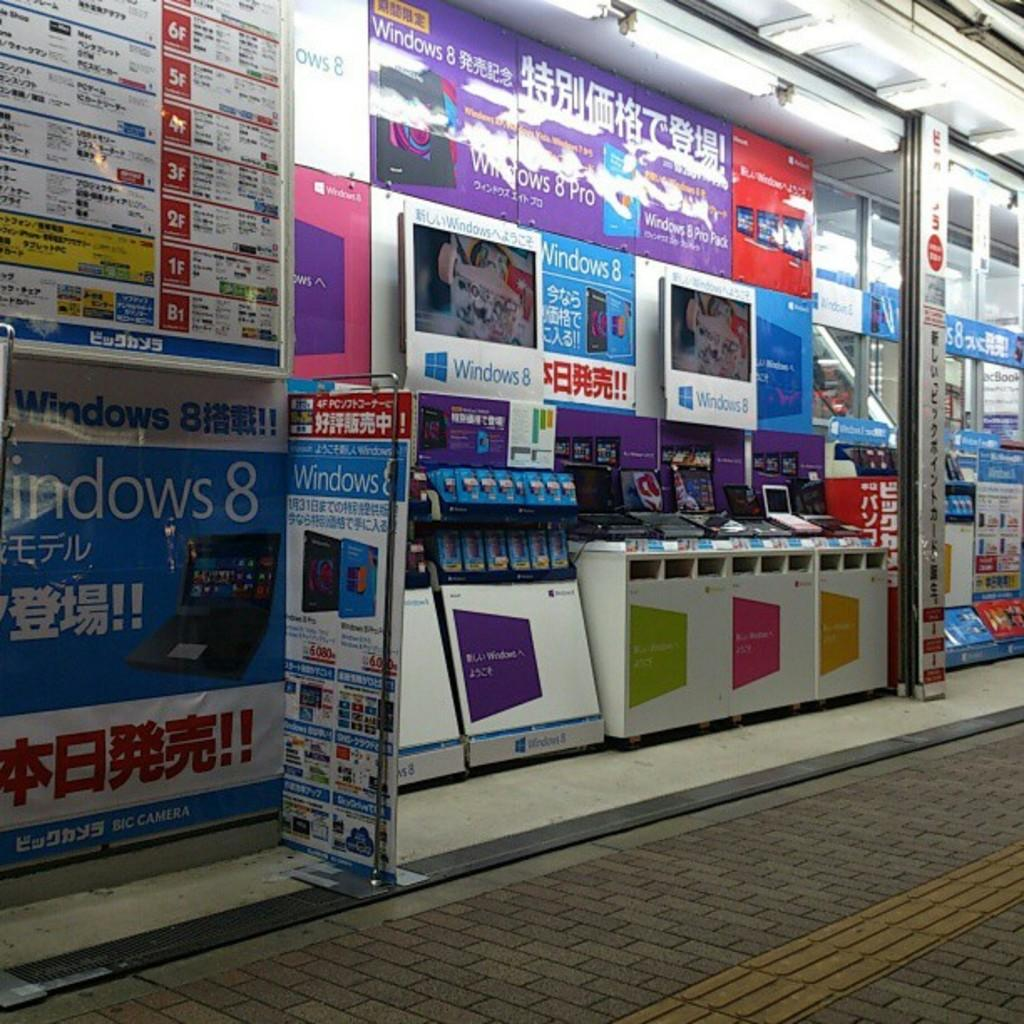<image>
Give a short and clear explanation of the subsequent image. A colorful wall includes ads for Windows 8 that are blue. 